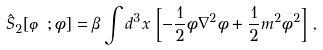<formula> <loc_0><loc_0><loc_500><loc_500>\hat { S } _ { 2 } [ \varphi ; \phi ] = \beta \int d ^ { 3 } x \, \left [ - \frac { 1 } { 2 } \phi \nabla ^ { 2 } \phi + \frac { 1 } { 2 } m ^ { 2 } \phi ^ { 2 } \right ] \, ,</formula> 